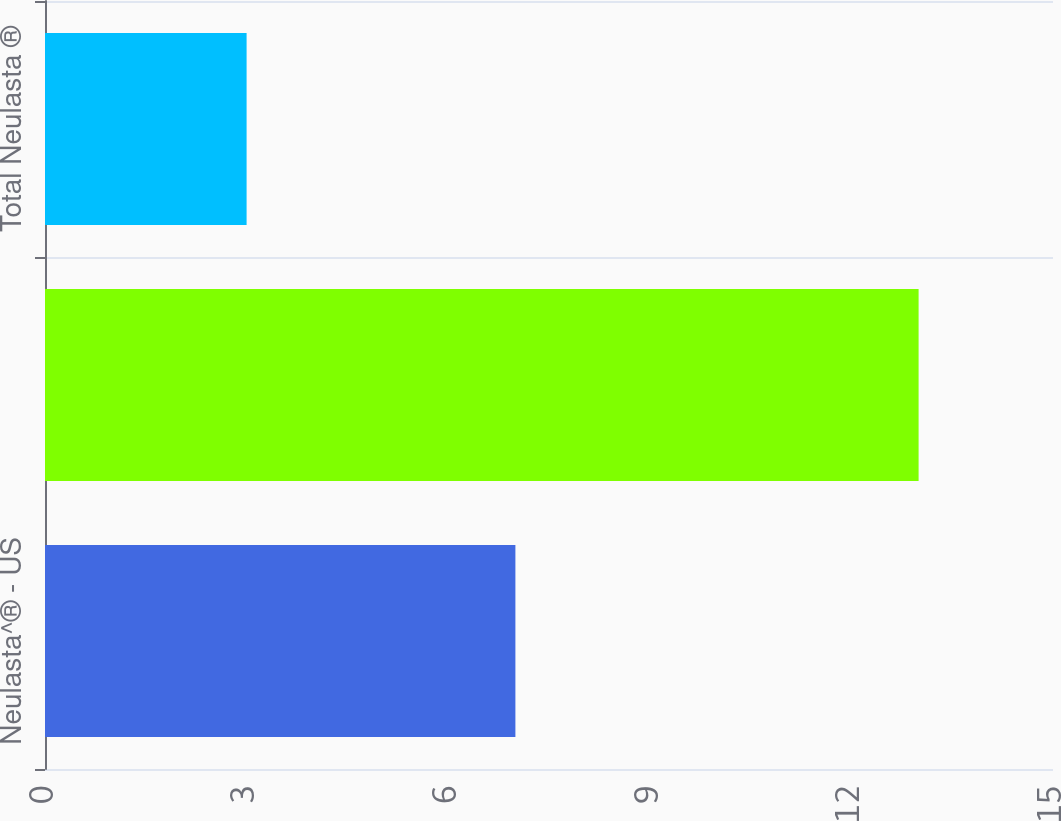<chart> <loc_0><loc_0><loc_500><loc_500><bar_chart><fcel>Neulasta^® - US<fcel>Neulasta^® - ROW<fcel>Total Neulasta ®<nl><fcel>7<fcel>13<fcel>3<nl></chart> 